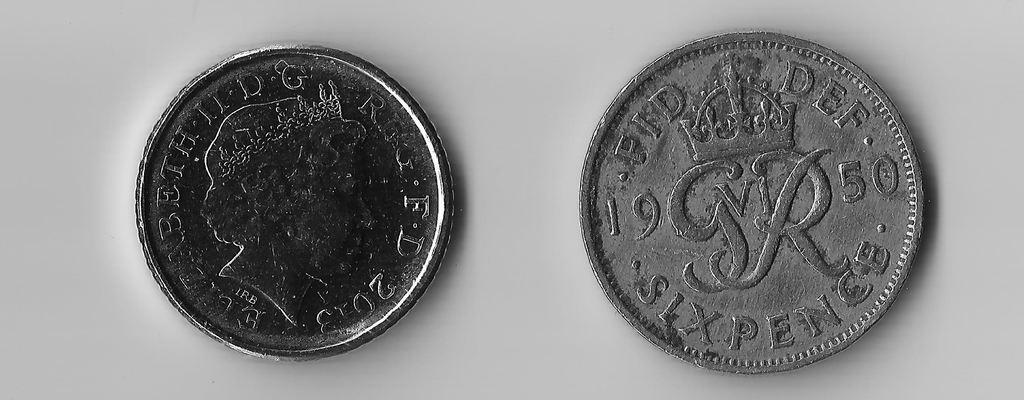<image>
Write a terse but informative summary of the picture. An old Queen Elizabeth II silver coin next to a six pence from 1950 